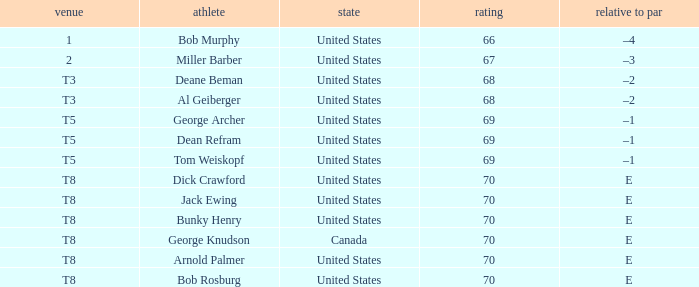From which country does george archer hail? United States. 